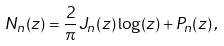Convert formula to latex. <formula><loc_0><loc_0><loc_500><loc_500>N _ { n } ( z ) = \frac { 2 } { \pi } J _ { n } ( z ) \log ( z ) + P _ { n } ( z ) \, ,</formula> 